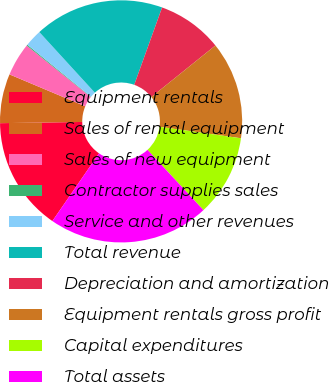Convert chart to OTSL. <chart><loc_0><loc_0><loc_500><loc_500><pie_chart><fcel>Equipment rentals<fcel>Sales of rental equipment<fcel>Sales of new equipment<fcel>Contractor supplies sales<fcel>Service and other revenues<fcel>Total revenue<fcel>Depreciation and amortization<fcel>Equipment rentals gross profit<fcel>Capital expenditures<fcel>Total assets<nl><fcel>15.16%<fcel>6.58%<fcel>4.43%<fcel>0.14%<fcel>2.29%<fcel>17.3%<fcel>8.72%<fcel>13.01%<fcel>10.87%<fcel>21.51%<nl></chart> 